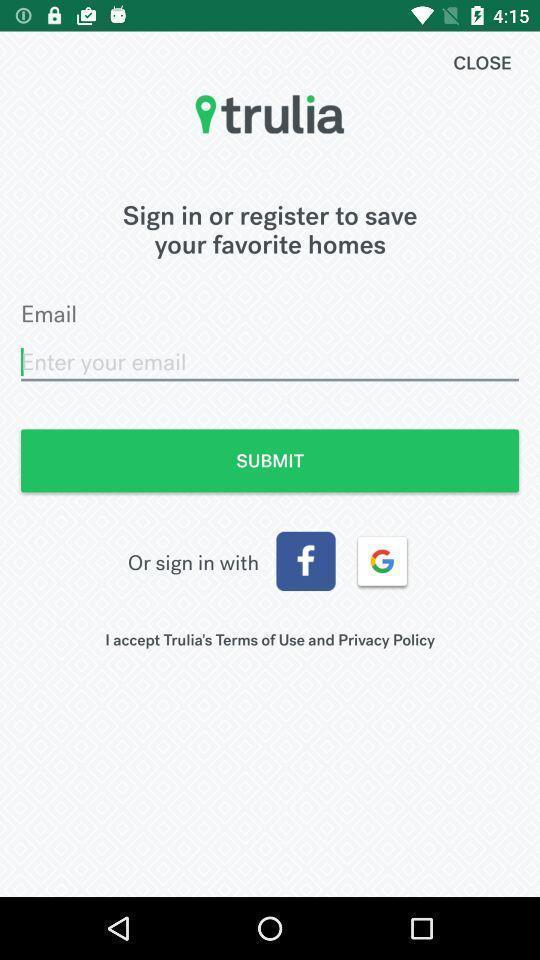What is the overall content of this screenshot? Sign in page. 